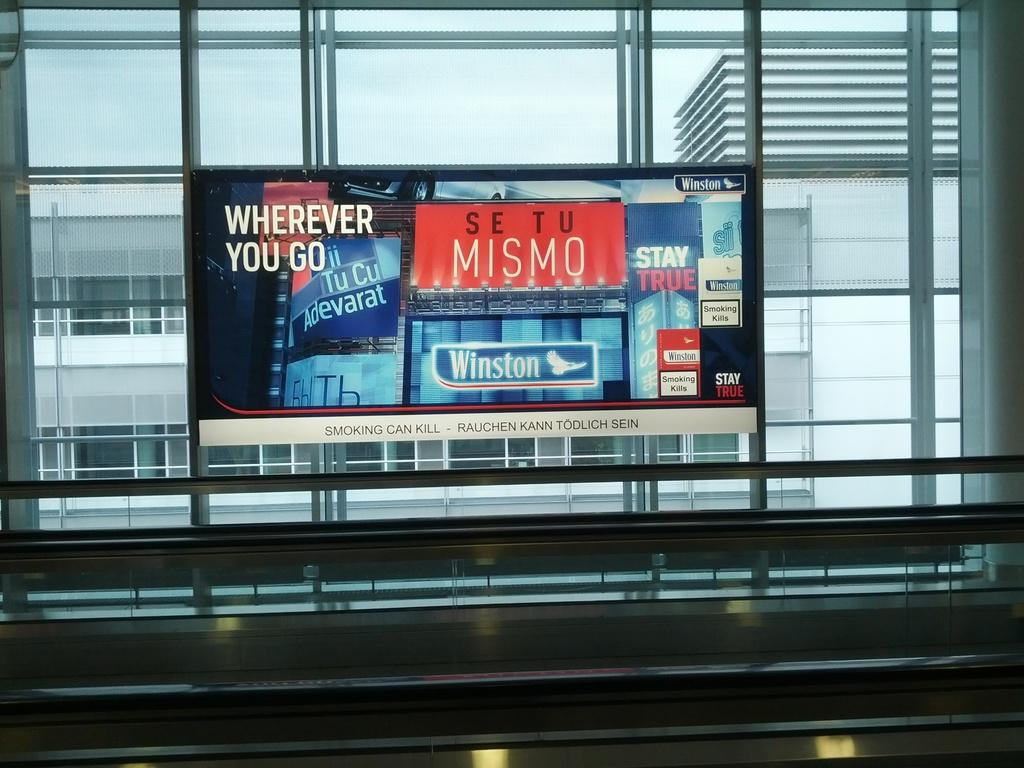What type of structure is present in the image? There is a glass window in the image. What can be seen through the glass window? Other buildings are visible through the glass window. What electronic device is present in the image? There is a television in the image. What is displayed on the television? Text is displayed on the television. What is the weather condition in the image? The sky is visible in the image and appears cloudy. Can you see a ship sailing in the basin in the image? There is no ship or basin present in the image. What type of payment method is accepted at the store shown on the television? The image does not show a store or any payment method; it only displays text on the television. 